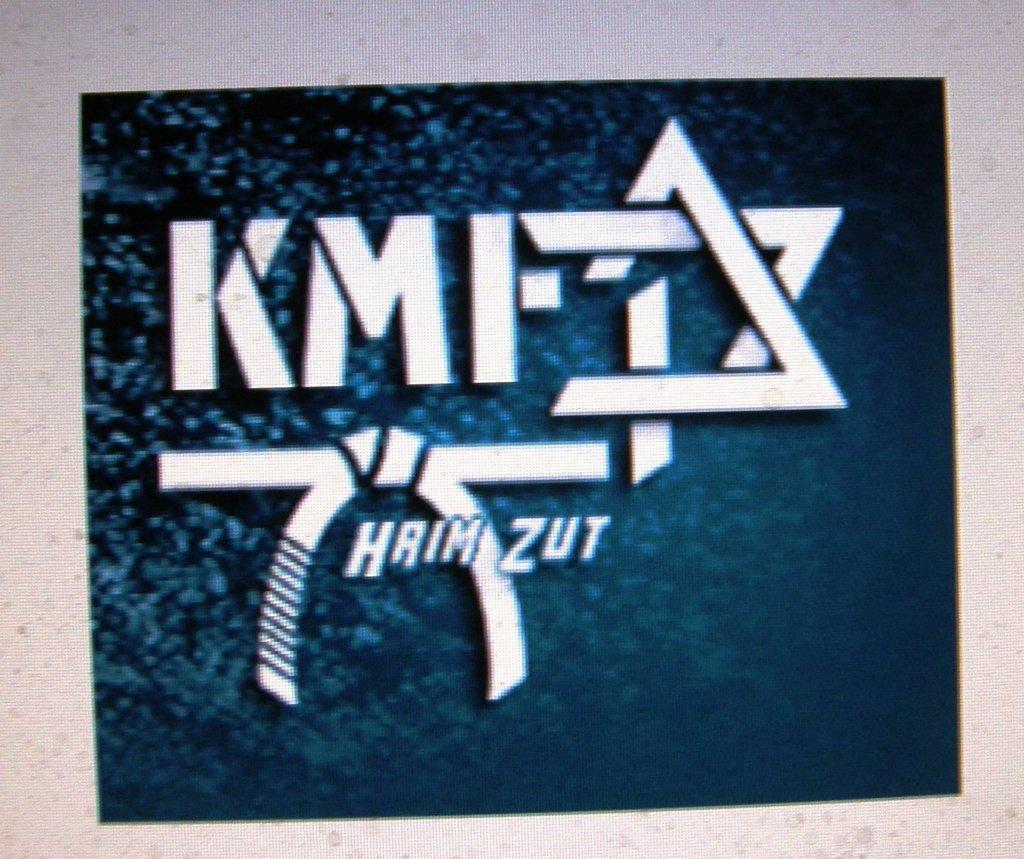Could you give a brief overview of what you see in this image? In the center of the image there is some text on the blue color surface. 